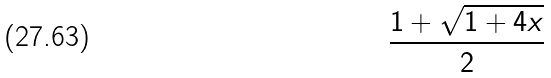<formula> <loc_0><loc_0><loc_500><loc_500>\frac { 1 + \sqrt { 1 + 4 x } } { 2 }</formula> 